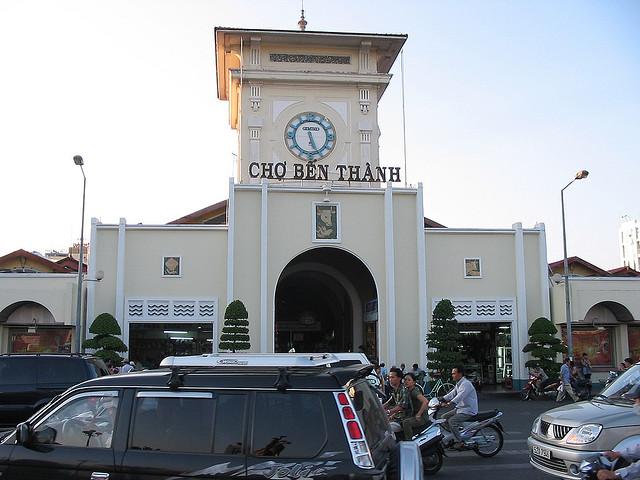Are both street lights designed the same?
Concise answer only. Yes. Is the sky cloudy?
Write a very short answer. No. What time is it?
Write a very short answer. 5:25. What is the name of this building?
Write a very short answer. Cho ben thanh. 